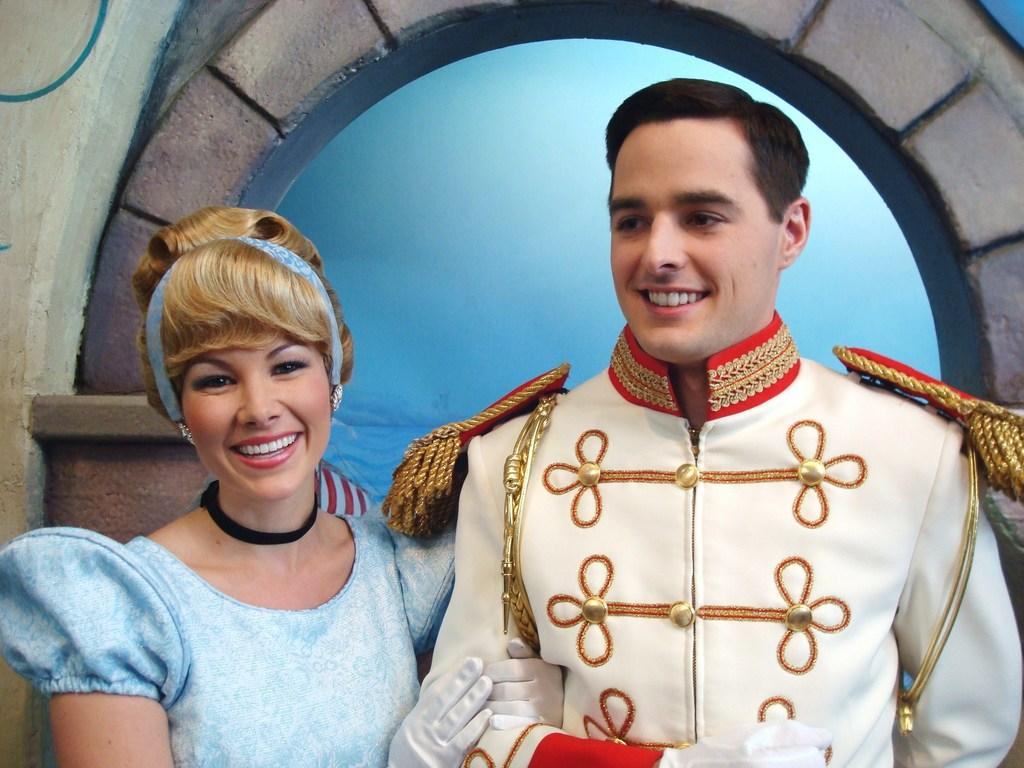Who or what can be seen in the image? There are people in the image. What are the people doing in the image? The people are standing. What is the facial expression of the people in the image? The people are smiling. What are the people wearing in the image? The people are wearing costumes. What type of hands can be seen holding the dolls in the image? There are no dolls present in the image, so there are no hands holding dolls. 